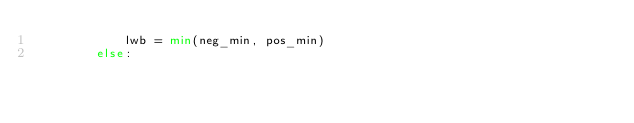Convert code to text. <code><loc_0><loc_0><loc_500><loc_500><_Python_>            lwb = min(neg_min, pos_min)
        else:</code> 